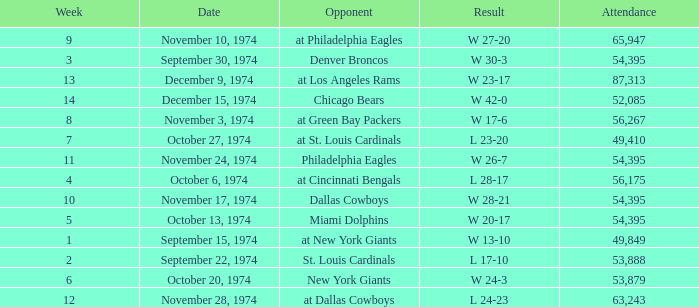What was the result of the game where 63,243 people attended after week 9? W 23-17. 